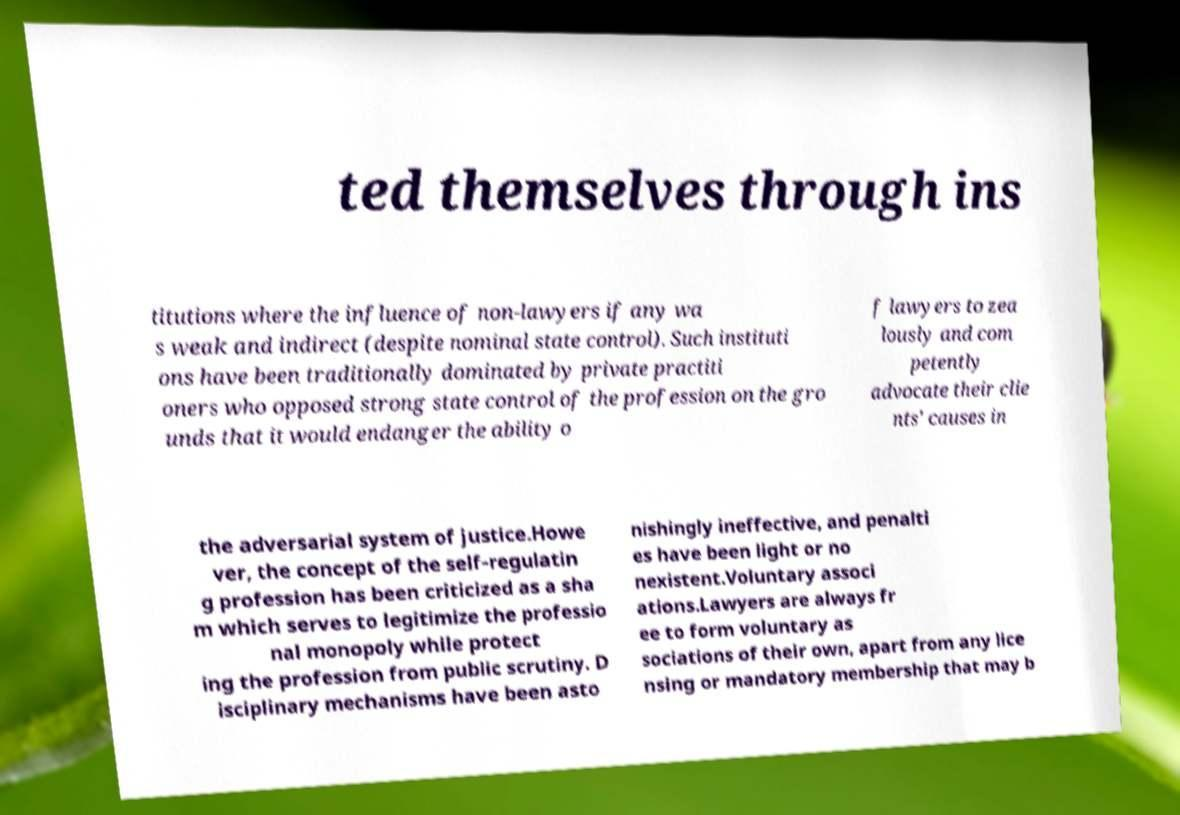Can you read and provide the text displayed in the image?This photo seems to have some interesting text. Can you extract and type it out for me? ted themselves through ins titutions where the influence of non-lawyers if any wa s weak and indirect (despite nominal state control). Such instituti ons have been traditionally dominated by private practiti oners who opposed strong state control of the profession on the gro unds that it would endanger the ability o f lawyers to zea lously and com petently advocate their clie nts' causes in the adversarial system of justice.Howe ver, the concept of the self-regulatin g profession has been criticized as a sha m which serves to legitimize the professio nal monopoly while protect ing the profession from public scrutiny. D isciplinary mechanisms have been asto nishingly ineffective, and penalti es have been light or no nexistent.Voluntary associ ations.Lawyers are always fr ee to form voluntary as sociations of their own, apart from any lice nsing or mandatory membership that may b 